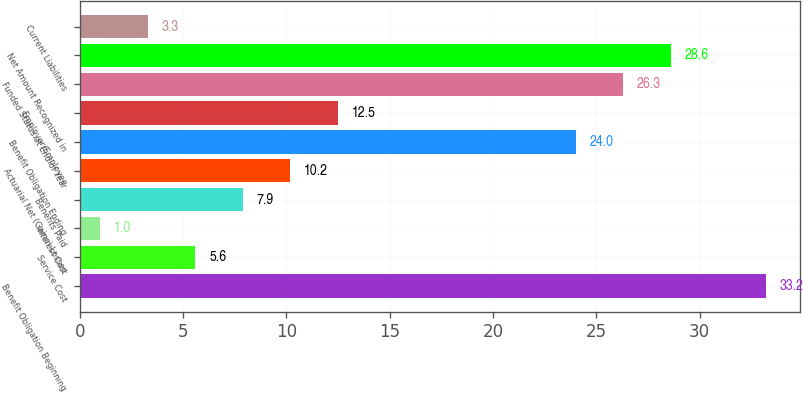Convert chart to OTSL. <chart><loc_0><loc_0><loc_500><loc_500><bar_chart><fcel>Benefit Obligation Beginning<fcel>Service Cost<fcel>Interest Cost<fcel>Benefits Paid<fcel>Actuarial Net (Gains) Losses<fcel>Benefit Obligation Ending<fcel>Employer/Employee<fcel>Funded Status at End of Year<fcel>Net Amount Recognized in<fcel>Current Liabilities<nl><fcel>33.2<fcel>5.6<fcel>1<fcel>7.9<fcel>10.2<fcel>24<fcel>12.5<fcel>26.3<fcel>28.6<fcel>3.3<nl></chart> 